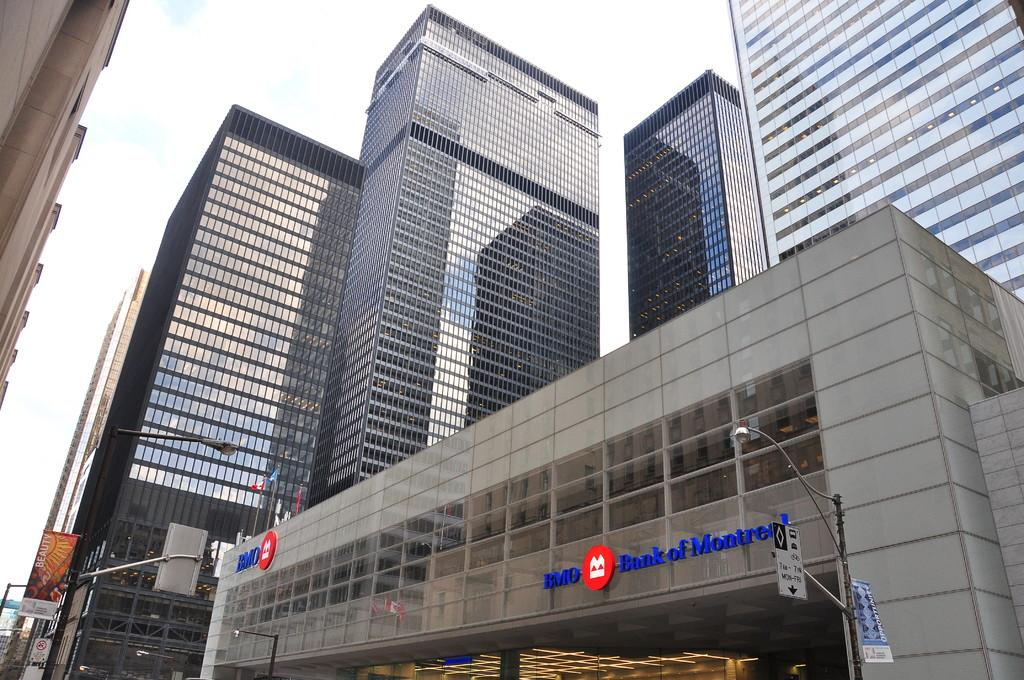<image>
Present a compact description of the photo's key features. The large building shown is for the Bank of Montreal. 